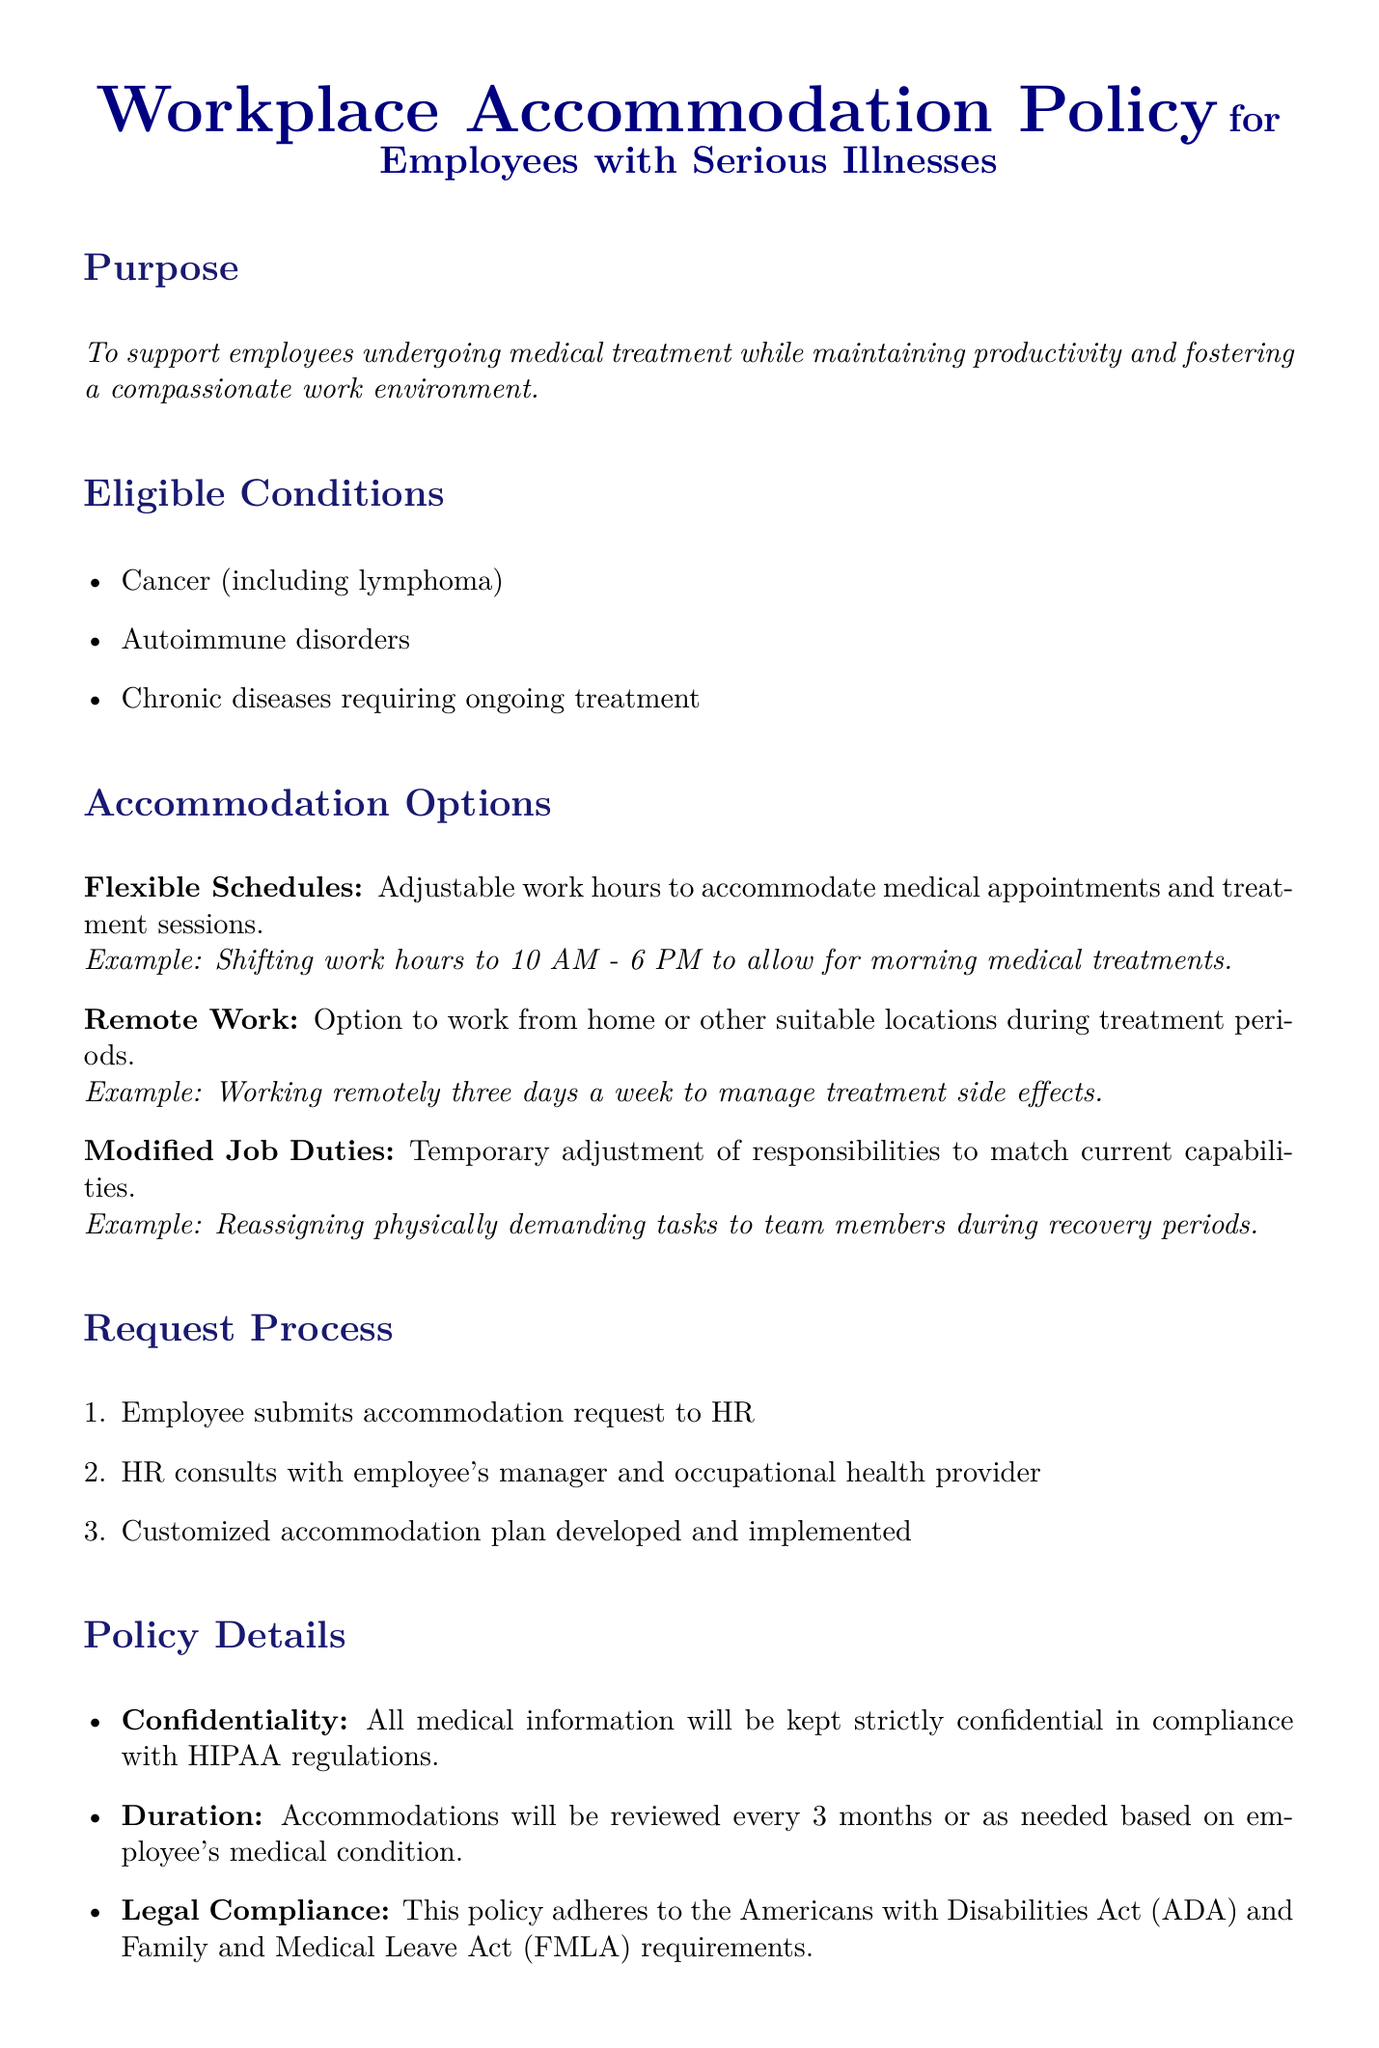What is the purpose of the policy? The purpose is stated in the document and describes the support provided to employees undergoing medical treatment.
Answer: To support employees undergoing medical treatment while maintaining productivity and fostering a compassionate work environment Which conditions are eligible for accommodation? The document lists specific conditions that qualify for workplace accommodations.
Answer: Cancer (including lymphoma), Autoimmune disorders, Chronic diseases requiring ongoing treatment What are the options available for accommodation? The document specifies three key accommodation options for employees during treatment.
Answer: Flexible Schedules, Remote Work, Modified Job Duties How often will accommodations be reviewed? The document provides information on how frequently accommodations will be reassessed.
Answer: Every 3 months Who should the employee contact to request accommodation? The document outlines the initial contact for accommodation requests.
Answer: HR What example is given for flexible schedules? The document provides a specific example related to flexible schedules for accommodation.
Answer: Shifting work hours to 10 AM - 6 PM to allow for morning medical treatments What is the confidentiality policy regarding medical information? The document explains how medical information will be handled under the policy.
Answer: All medical information will be kept strictly confidential in compliance with HIPAA regulations What contact information is provided for the Employee Assistance Program? The document gives a specific contact number for employees seeking assistance.
Answer: 1-800-123-4567 